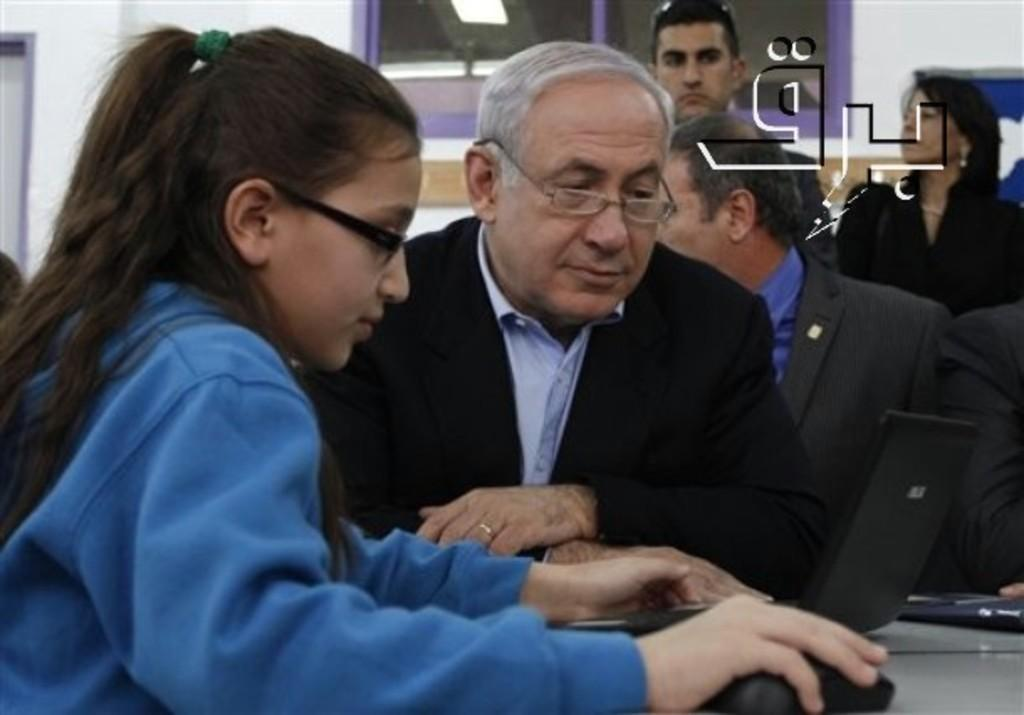What are the people in the image doing? There are people sitting and standing in the image. Can you describe the girl in the image? The girl in the image is holding a mouse in her hand. What type of dinner is being served in the image? There is no dinner present in the image; it only features people sitting, standing, and a girl holding a mouse. What type of agreement is being discussed in the image? There is no discussion or agreement present in the image; it only features people and a girl with a mouse. 